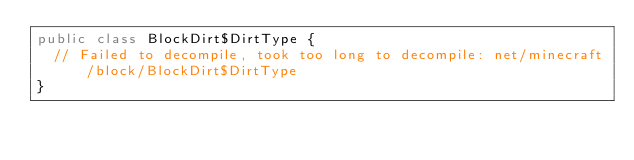Convert code to text. <code><loc_0><loc_0><loc_500><loc_500><_Java_>public class BlockDirt$DirtType {
	// Failed to decompile, took too long to decompile: net/minecraft/block/BlockDirt$DirtType
}</code> 